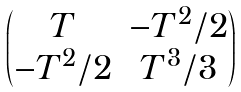<formula> <loc_0><loc_0><loc_500><loc_500>\begin{pmatrix} T & - T ^ { 2 } / 2 \\ - T ^ { 2 } / 2 & T ^ { 3 } / 3 \end{pmatrix}</formula> 